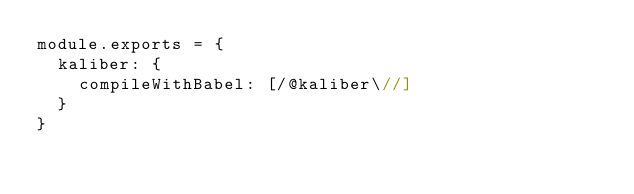Convert code to text. <code><loc_0><loc_0><loc_500><loc_500><_JavaScript_>module.exports = {
  kaliber: {
    compileWithBabel: [/@kaliber\//]
  }
}
</code> 